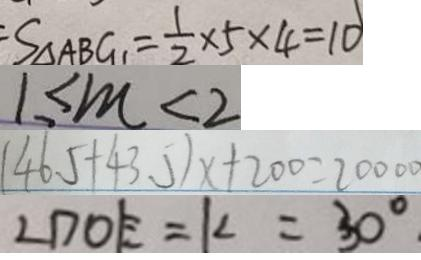<formula> <loc_0><loc_0><loc_500><loc_500>S _ { \Delta A B G } = \frac { 1 } { 2 } \times 5 \times 4 = 1 0 
 1 \leq m < 2 
 ( 4 6 . 5 + 4 3 . 5 ) x + 2 0 0 = 2 0 0 0 0 
 \angle D O E = k = 3 0 ^ { \circ } .</formula> 